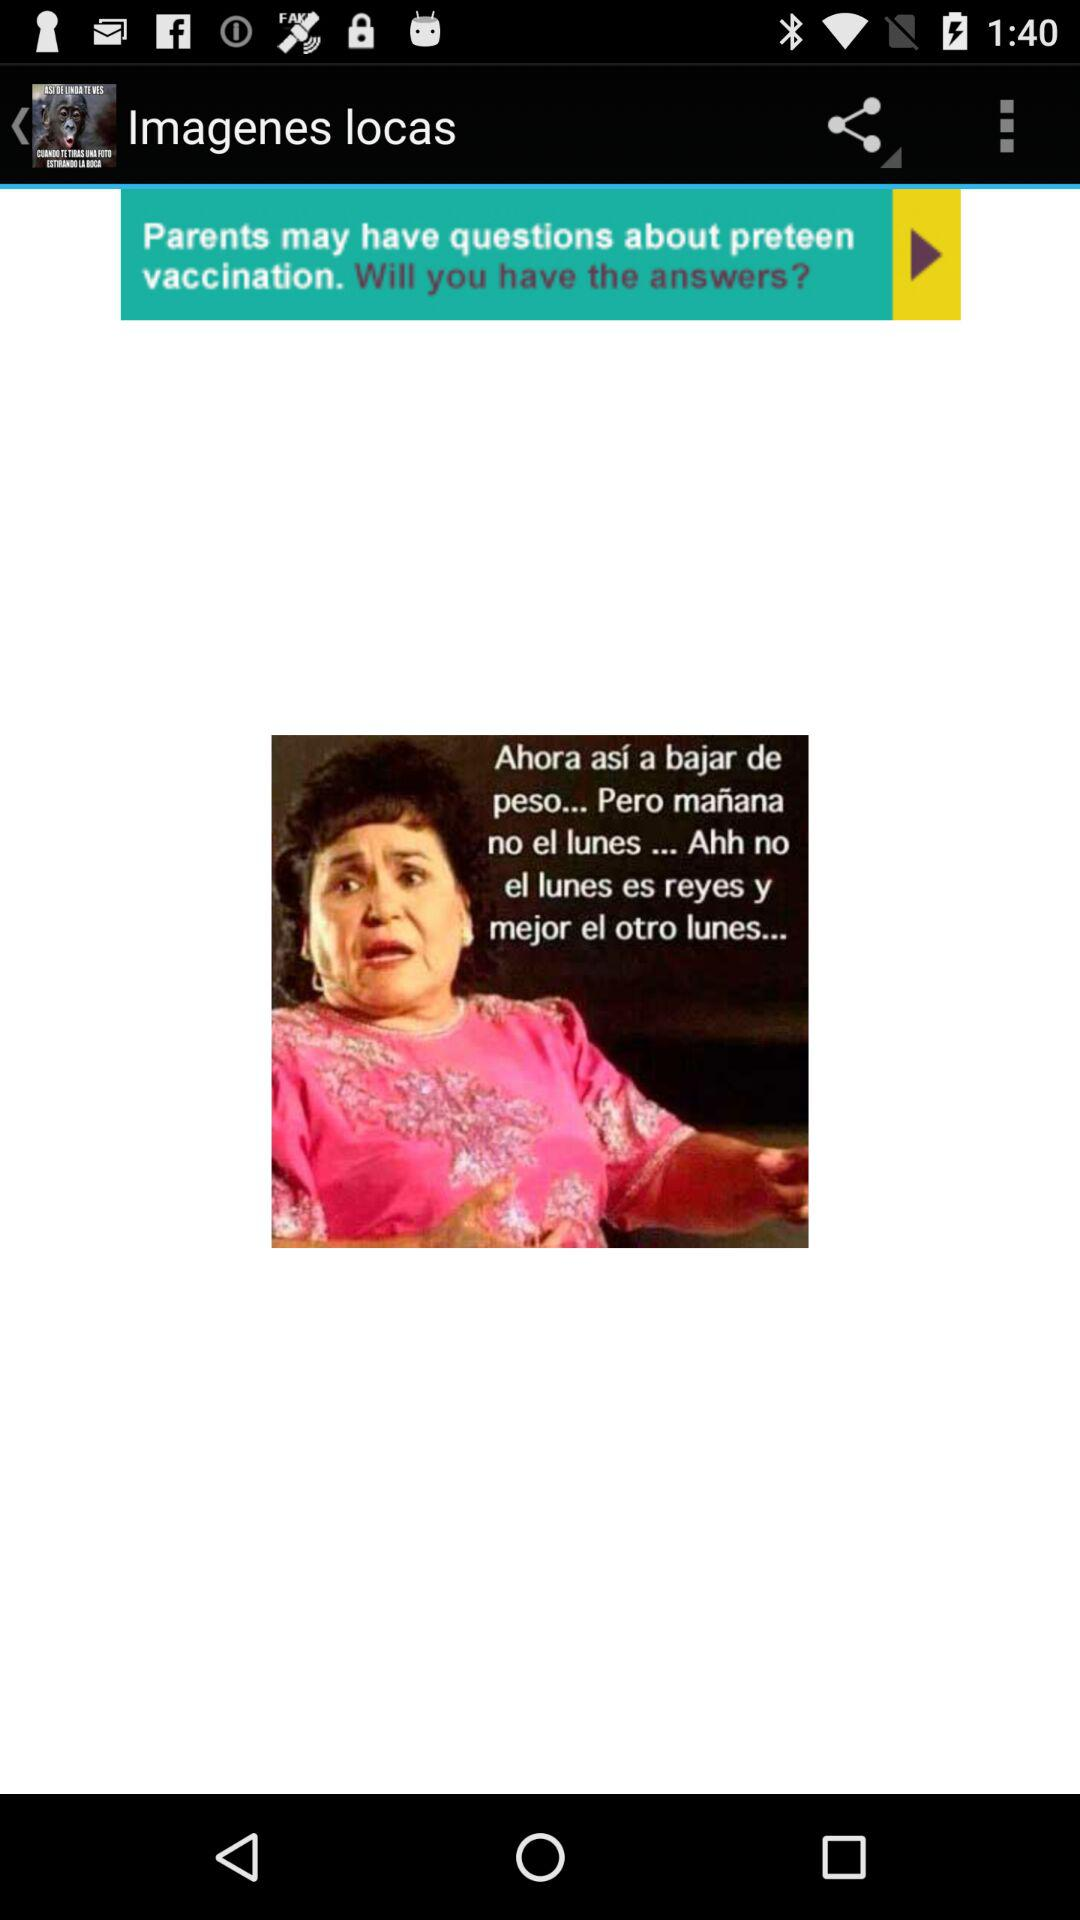With which applications can the image be shared?
When the provided information is insufficient, respond with <no answer>. <no answer> 